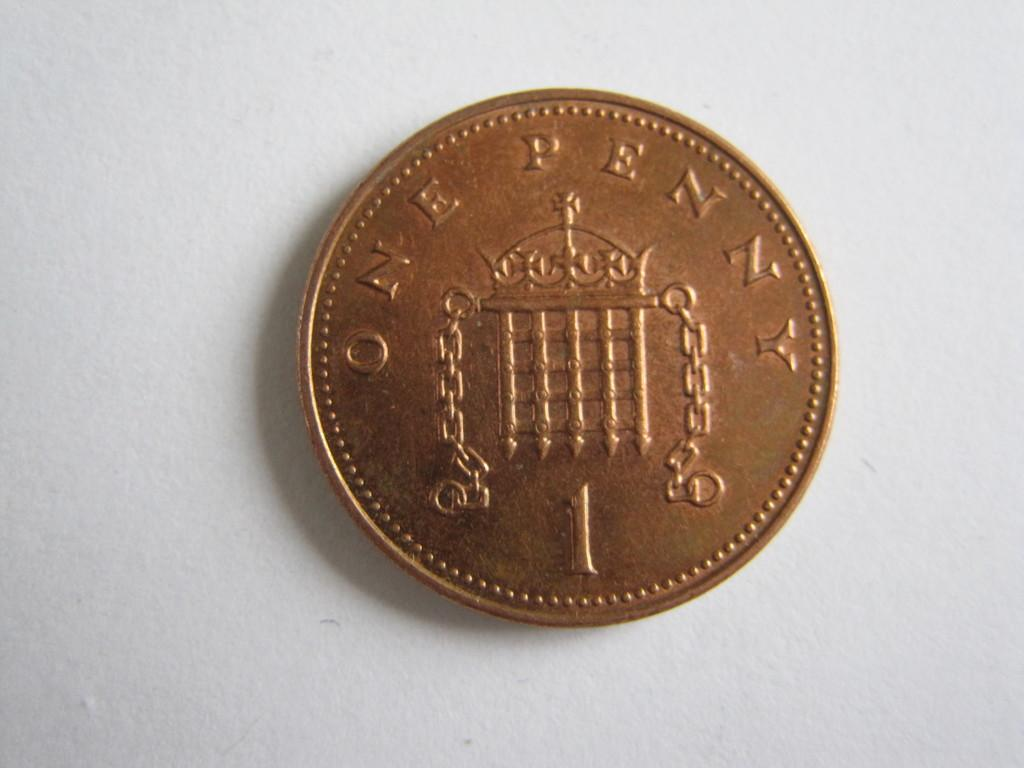<image>
Present a compact description of the photo's key features. A copper coin featuring the words ONE PENNY sits on top of a white surface. 